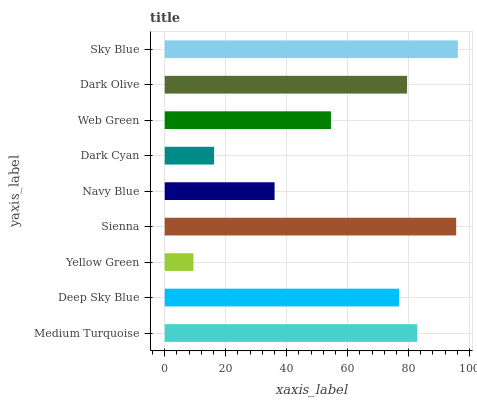Is Yellow Green the minimum?
Answer yes or no. Yes. Is Sky Blue the maximum?
Answer yes or no. Yes. Is Deep Sky Blue the minimum?
Answer yes or no. No. Is Deep Sky Blue the maximum?
Answer yes or no. No. Is Medium Turquoise greater than Deep Sky Blue?
Answer yes or no. Yes. Is Deep Sky Blue less than Medium Turquoise?
Answer yes or no. Yes. Is Deep Sky Blue greater than Medium Turquoise?
Answer yes or no. No. Is Medium Turquoise less than Deep Sky Blue?
Answer yes or no. No. Is Deep Sky Blue the high median?
Answer yes or no. Yes. Is Deep Sky Blue the low median?
Answer yes or no. Yes. Is Medium Turquoise the high median?
Answer yes or no. No. Is Dark Cyan the low median?
Answer yes or no. No. 